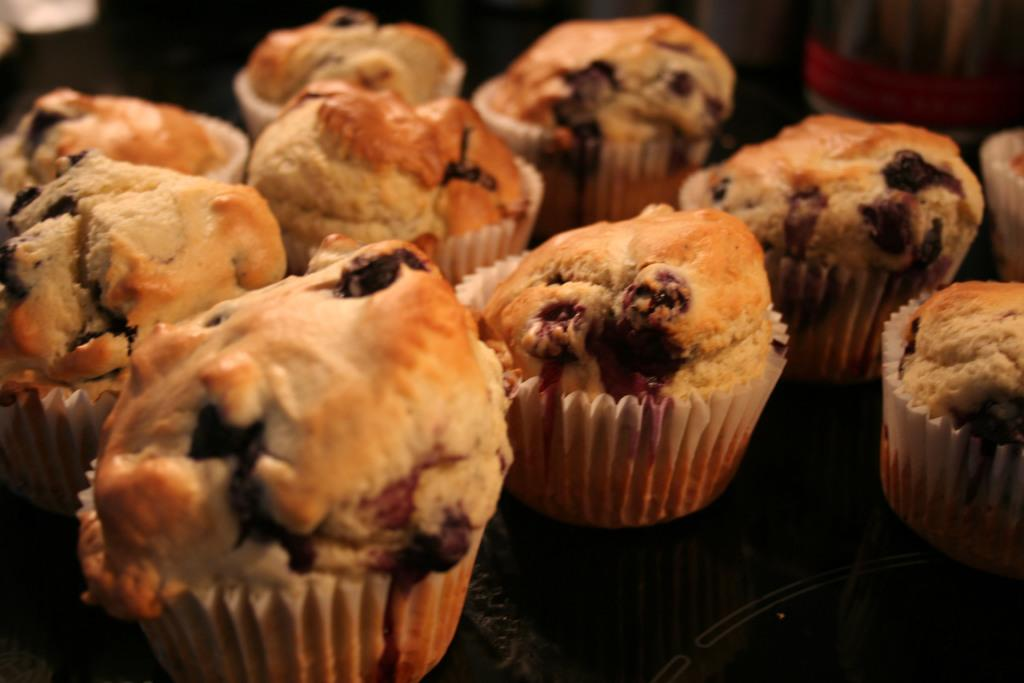What type of food can be seen in the image? There are muffins in the image. Can you see a pot in the image? There is no pot present in the image. Is there a squirrel visible in the image? There is no squirrel present in the image. 